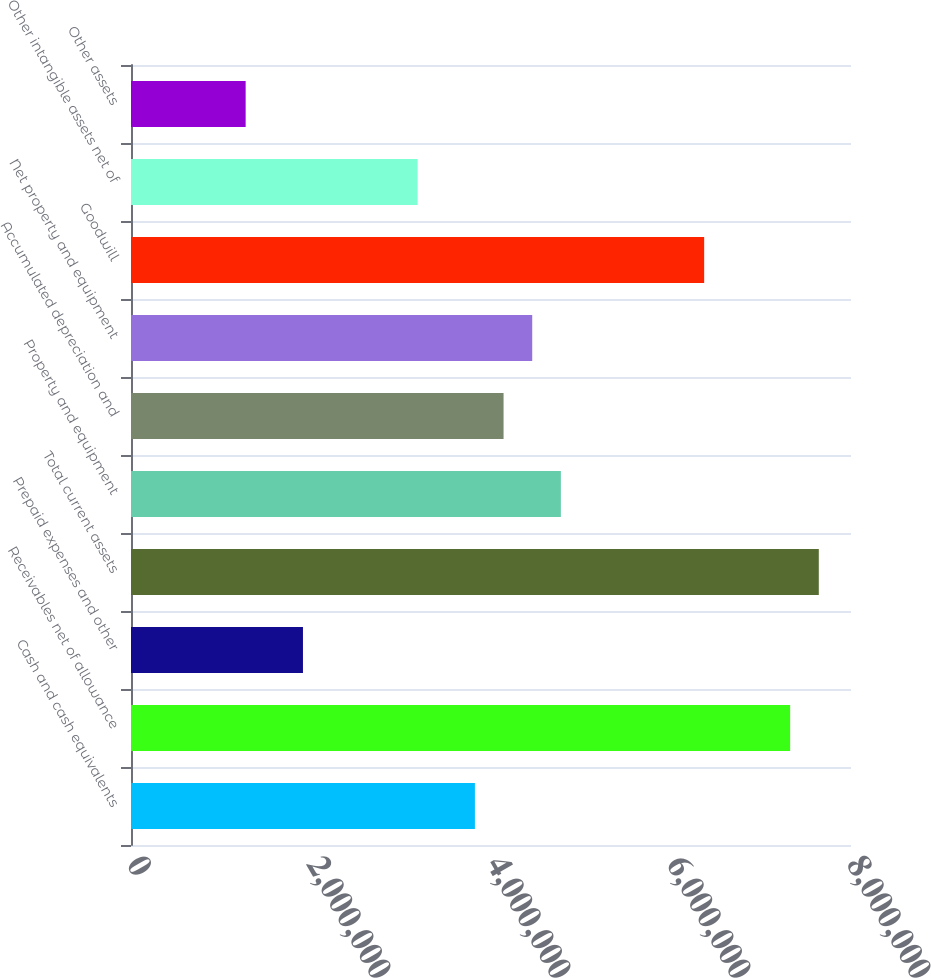Convert chart to OTSL. <chart><loc_0><loc_0><loc_500><loc_500><bar_chart><fcel>Cash and cash equivalents<fcel>Receivables net of allowance<fcel>Prepaid expenses and other<fcel>Total current assets<fcel>Property and equipment<fcel>Accumulated depreciation and<fcel>Net property and equipment<fcel>Goodwill<fcel>Other intangible assets net of<fcel>Other assets<nl><fcel>3.82119e+06<fcel>7.32374e+06<fcel>1.9107e+06<fcel>7.64216e+06<fcel>4.77643e+06<fcel>4.1396e+06<fcel>4.45801e+06<fcel>6.3685e+06<fcel>3.18436e+06<fcel>1.27387e+06<nl></chart> 